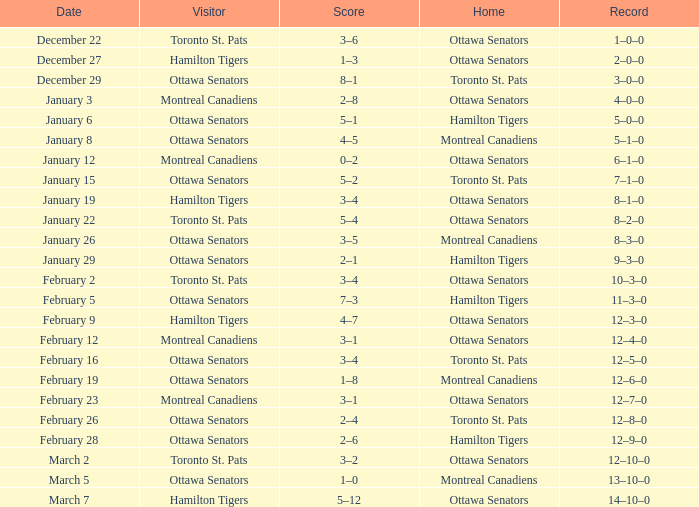What is the record for the game on January 19? 8–1–0. 